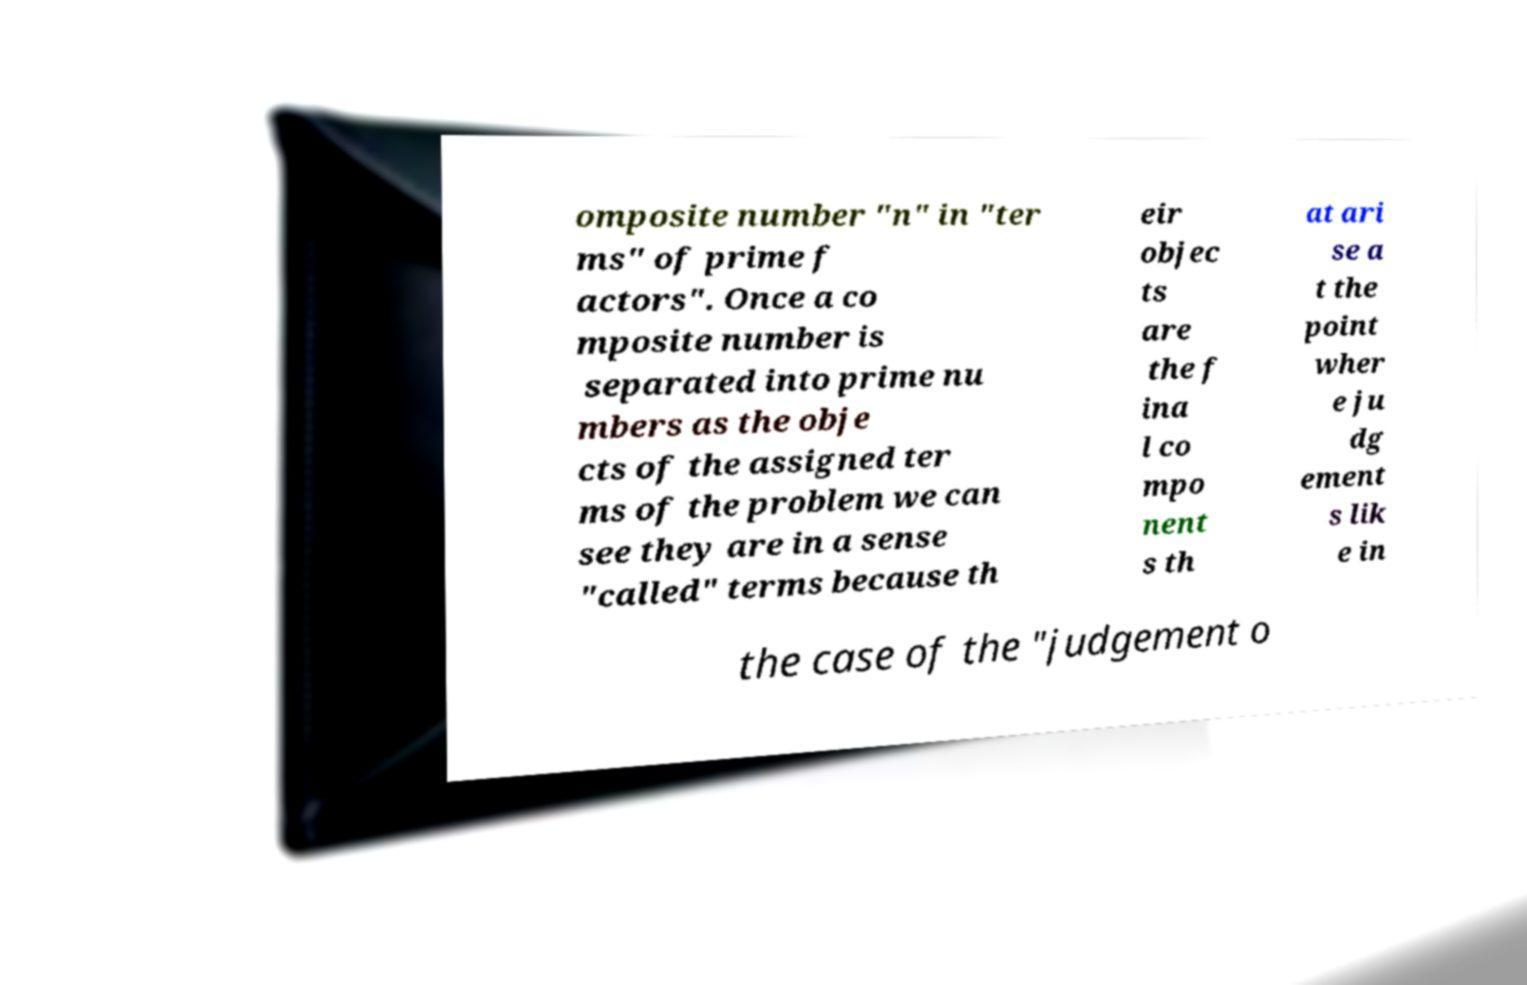There's text embedded in this image that I need extracted. Can you transcribe it verbatim? omposite number "n" in "ter ms" of prime f actors". Once a co mposite number is separated into prime nu mbers as the obje cts of the assigned ter ms of the problem we can see they are in a sense "called" terms because th eir objec ts are the f ina l co mpo nent s th at ari se a t the point wher e ju dg ement s lik e in the case of the "judgement o 